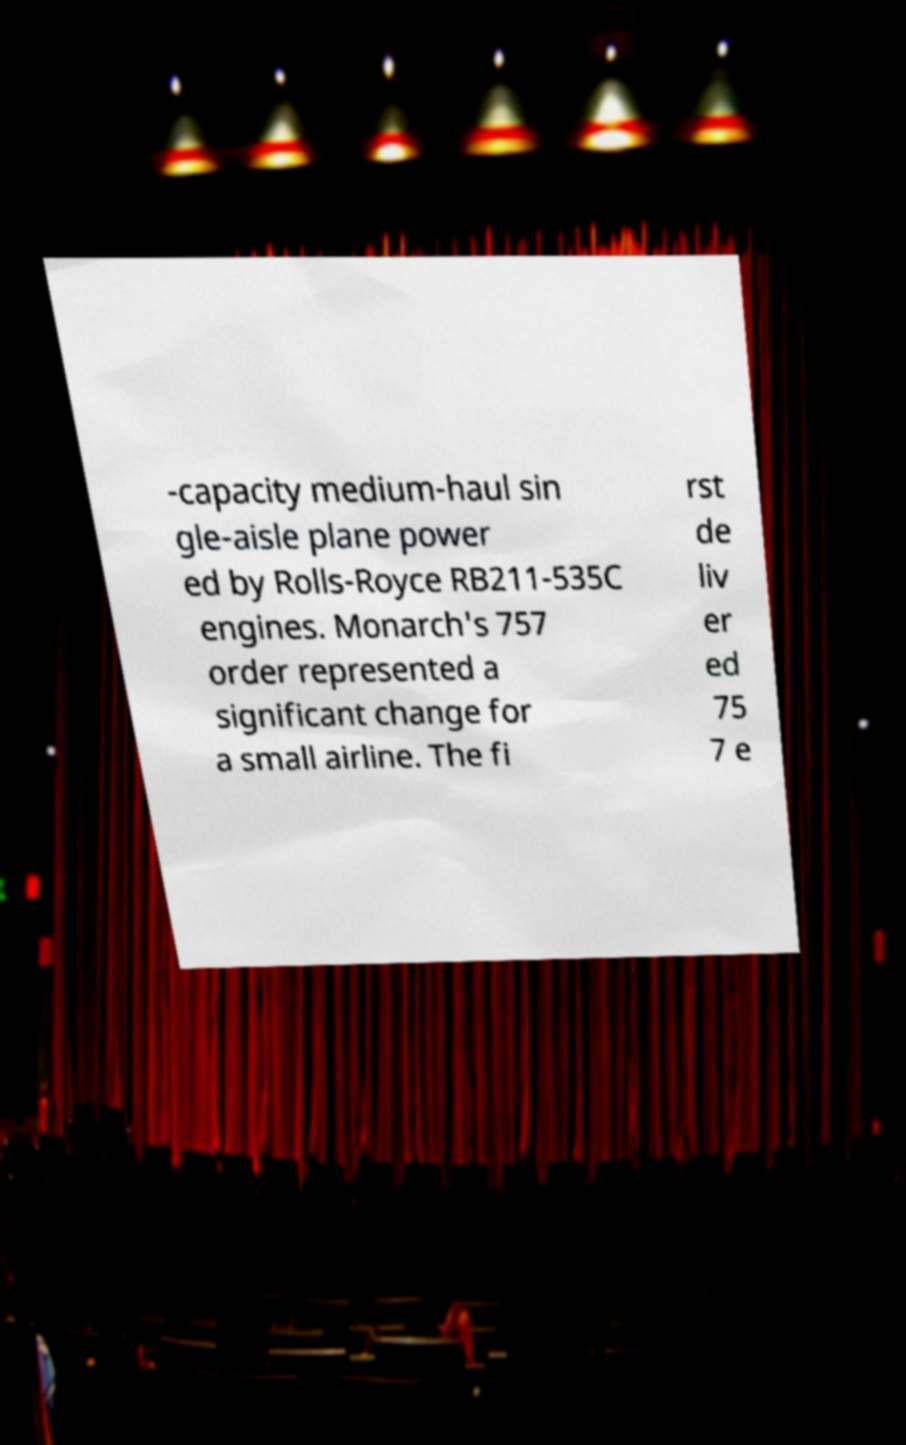Please read and relay the text visible in this image. What does it say? -capacity medium-haul sin gle-aisle plane power ed by Rolls-Royce RB211-535C engines. Monarch's 757 order represented a significant change for a small airline. The fi rst de liv er ed 75 7 e 